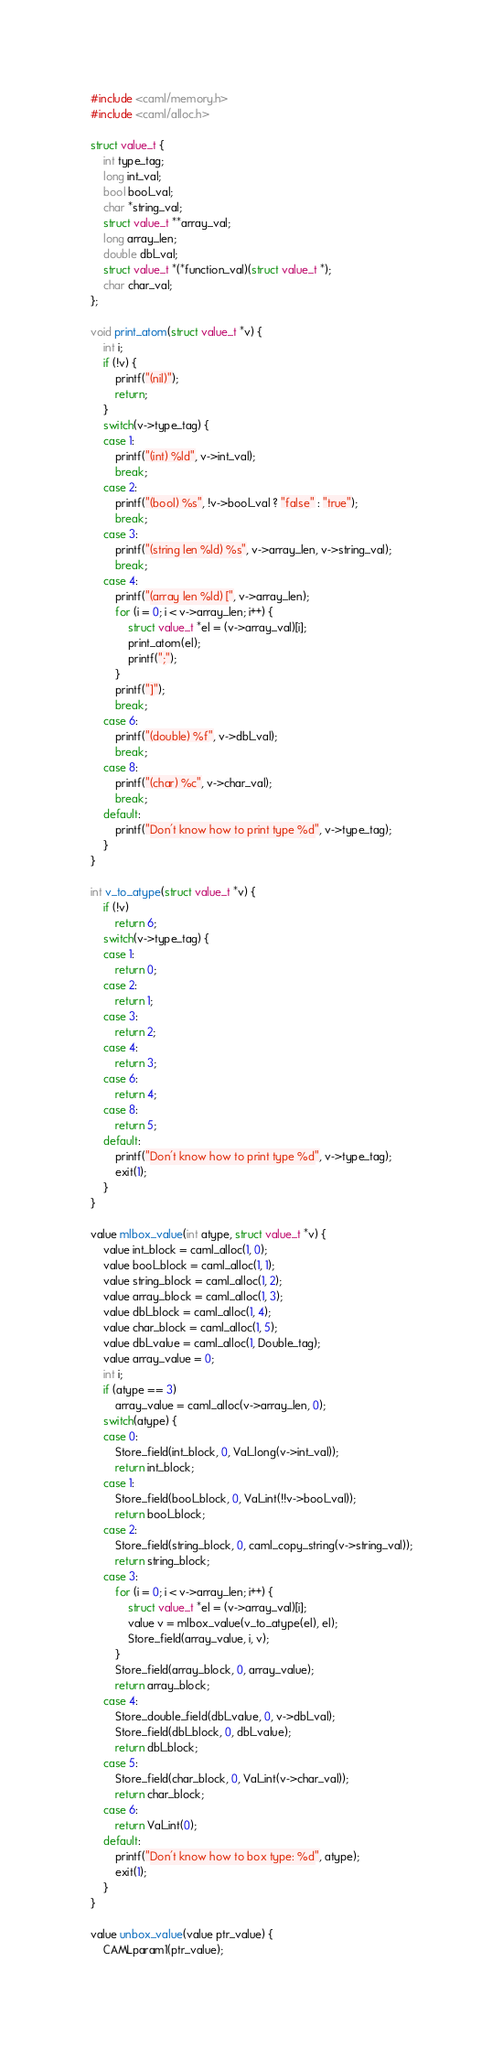Convert code to text. <code><loc_0><loc_0><loc_500><loc_500><_C_>#include <caml/memory.h>
#include <caml/alloc.h>

struct value_t {
	int type_tag;
	long int_val;
	bool bool_val;
	char *string_val;
	struct value_t **array_val;
	long array_len;
	double dbl_val;
	struct value_t *(*function_val)(struct value_t *);
	char char_val;
};

void print_atom(struct value_t *v) {
	int i;
	if (!v) {
		printf("(nil)");
		return;
	}
	switch(v->type_tag) {
	case 1:
		printf("(int) %ld", v->int_val);
		break;
	case 2:
		printf("(bool) %s", !v->bool_val ? "false" : "true");
		break;
	case 3:
		printf("(string len %ld) %s", v->array_len, v->string_val);
		break;
	case 4:
		printf("(array len %ld) [", v->array_len);
		for (i = 0; i < v->array_len; i++) {
			struct value_t *el = (v->array_val)[i];
			print_atom(el);
			printf(";");
		}
		printf("]");
		break;
	case 6:
		printf("(double) %f", v->dbl_val);
		break;
	case 8:
		printf("(char) %c", v->char_val);
		break;
	default:
		printf("Don't know how to print type %d", v->type_tag);
	}
}

int v_to_atype(struct value_t *v) {
	if (!v)
		return 6;
	switch(v->type_tag) {
	case 1:
		return 0;
	case 2:
		return 1;
	case 3:
		return 2;
	case 4:
		return 3;
	case 6:
		return 4;
	case 8:
		return 5;
	default:
		printf("Don't know how to print type %d", v->type_tag);
		exit(1);
	}
}

value mlbox_value(int atype, struct value_t *v) {
	value int_block = caml_alloc(1, 0);
	value bool_block = caml_alloc(1, 1);
	value string_block = caml_alloc(1, 2);
	value array_block = caml_alloc(1, 3);
	value dbl_block = caml_alloc(1, 4);
	value char_block = caml_alloc(1, 5);
	value dbl_value = caml_alloc(1, Double_tag);
	value array_value = 0;
	int i;
	if (atype == 3)
		array_value = caml_alloc(v->array_len, 0);
	switch(atype) {
	case 0:
		Store_field(int_block, 0, Val_long(v->int_val));
		return int_block;
	case 1:
		Store_field(bool_block, 0, Val_int(!!v->bool_val));
		return bool_block;
	case 2:
		Store_field(string_block, 0, caml_copy_string(v->string_val));
		return string_block;
	case 3:
		for (i = 0; i < v->array_len; i++) {
			struct value_t *el = (v->array_val)[i];
			value v = mlbox_value(v_to_atype(el), el);
			Store_field(array_value, i, v);
		}
		Store_field(array_block, 0, array_value);
		return array_block;
	case 4:
		Store_double_field(dbl_value, 0, v->dbl_val);
		Store_field(dbl_block, 0, dbl_value);
		return dbl_block;
	case 5:
		Store_field(char_block, 0, Val_int(v->char_val));
		return char_block;
	case 6:
		return Val_int(0);
	default:
		printf("Don't know how to box type: %d", atype);
		exit(1);
	}
}

value unbox_value(value ptr_value) {
	CAMLparam1(ptr_value);</code> 